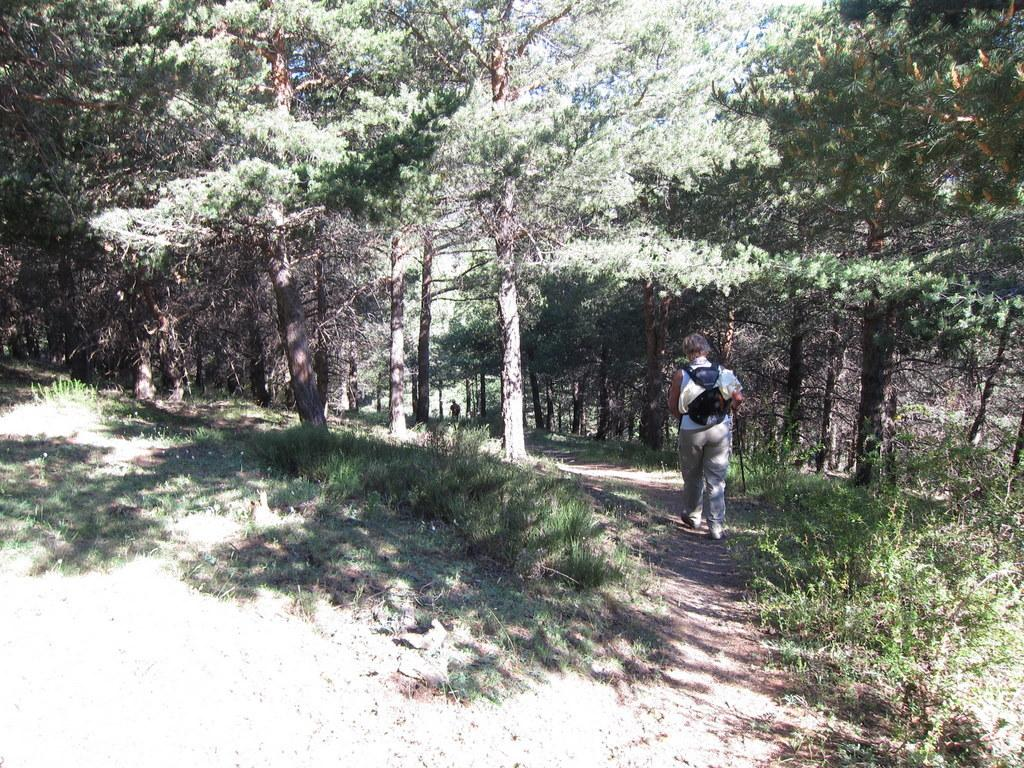Who is present in the image? There is a person in the image. What is the person holding or carrying? The person is carrying a bag. Where is the person walking? The person is walking on a small walkway. What can be seen on the sides of the walkway? There are trees on the sides of the walkway. What type of ground surface is visible in the image? There is grass on the ground. How many bananas are hanging from the trees in the image? There are no bananas visible in the image; only trees are present on the sides of the walkway. 